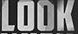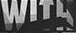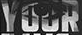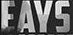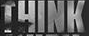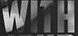Identify the words shown in these images in order, separated by a semicolon. LOOK; WITH; YOUR; EAYS; THINK; WITH 